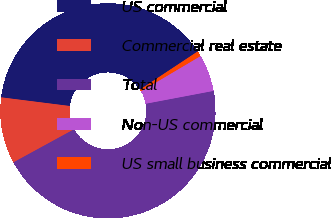Convert chart. <chart><loc_0><loc_0><loc_500><loc_500><pie_chart><fcel>US commercial<fcel>Commercial real estate<fcel>Total<fcel>Non-US commercial<fcel>US small business commercial<nl><fcel>38.7%<fcel>9.95%<fcel>45.02%<fcel>5.53%<fcel>0.79%<nl></chart> 